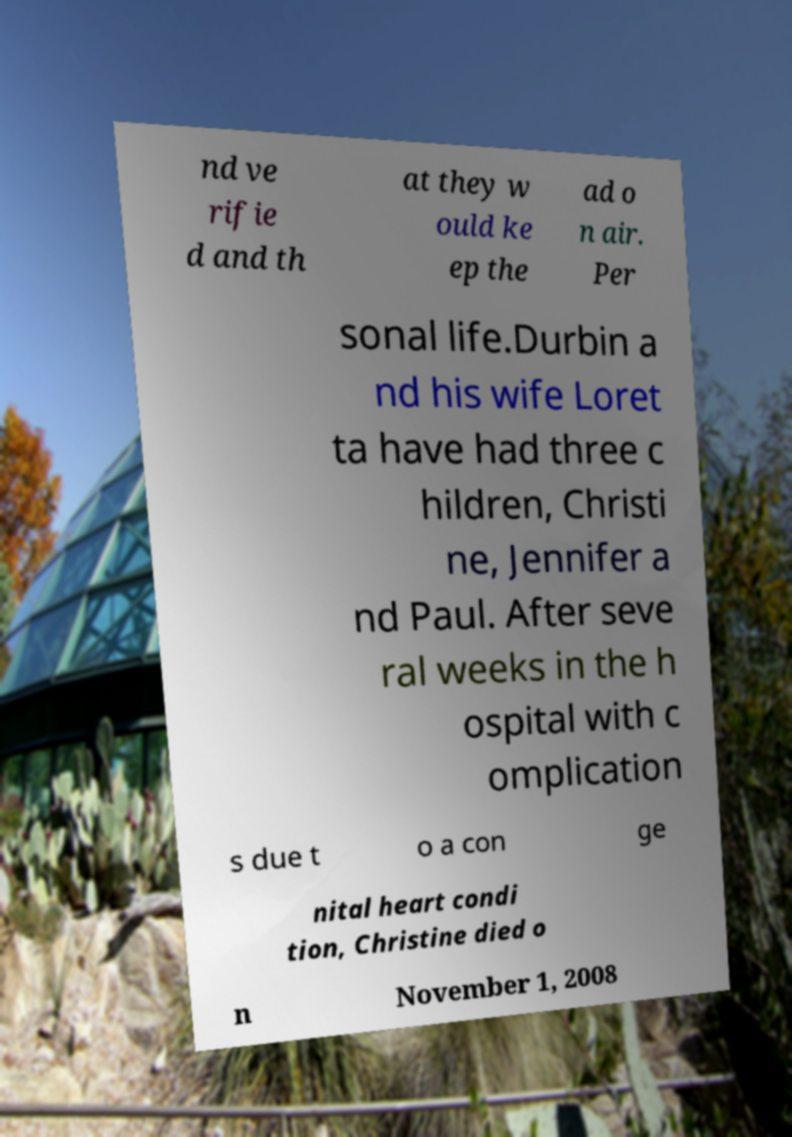Could you assist in decoding the text presented in this image and type it out clearly? nd ve rifie d and th at they w ould ke ep the ad o n air. Per sonal life.Durbin a nd his wife Loret ta have had three c hildren, Christi ne, Jennifer a nd Paul. After seve ral weeks in the h ospital with c omplication s due t o a con ge nital heart condi tion, Christine died o n November 1, 2008 